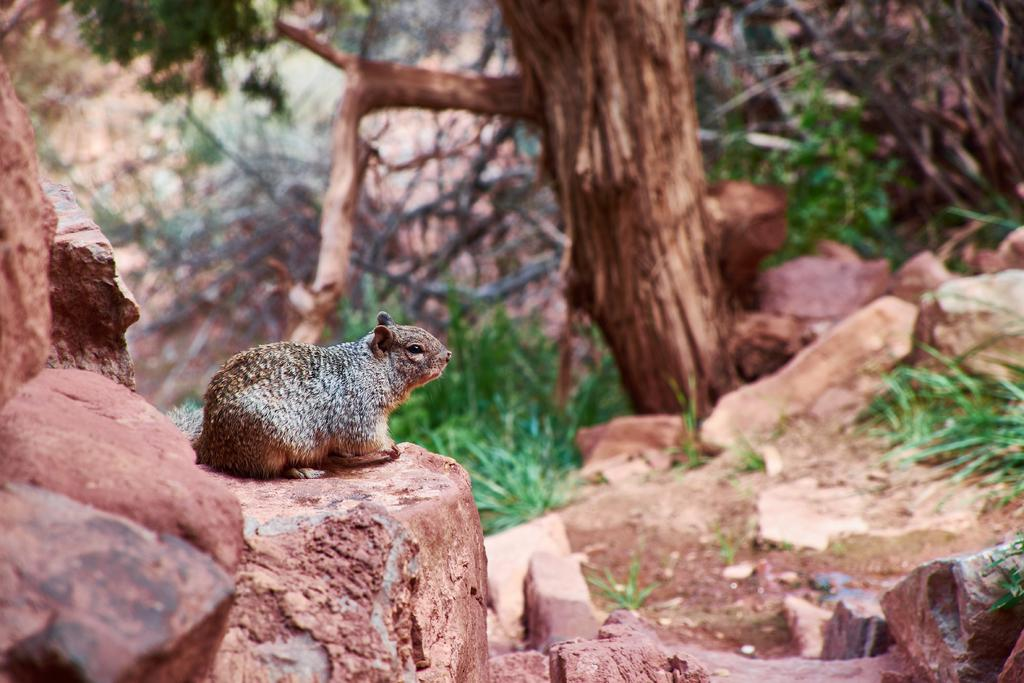What is the main subject of the image? There is an animal on a rock in the image. What can be seen on the land in the image? There are rocks on the land in the image. What is growing on the rocks? The rocks have some grass on them. What is visible in the background of the image? There are trees in the background of the image. Can you see the vein of copper running through the rocks in the image? There is no mention of a vein of copper in the image, so it cannot be seen. 